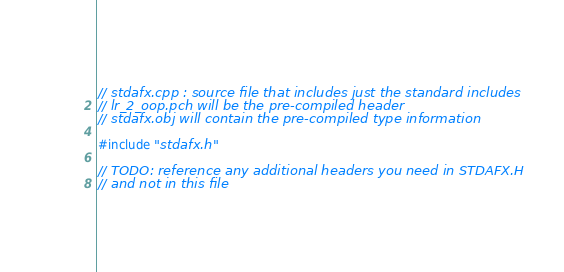Convert code to text. <code><loc_0><loc_0><loc_500><loc_500><_C++_>// stdafx.cpp : source file that includes just the standard includes
// lr_2_oop.pch will be the pre-compiled header
// stdafx.obj will contain the pre-compiled type information

#include "stdafx.h"

// TODO: reference any additional headers you need in STDAFX.H
// and not in this file
</code> 